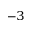<formula> <loc_0><loc_0><loc_500><loc_500>^ { - 3 }</formula> 